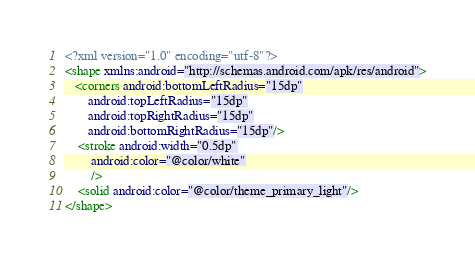<code> <loc_0><loc_0><loc_500><loc_500><_XML_><?xml version="1.0" encoding="utf-8"?>
<shape xmlns:android="http://schemas.android.com/apk/res/android">
   <corners android:bottomLeftRadius="15dp"
       android:topLeftRadius="15dp"
       android:topRightRadius="15dp"
       android:bottomRightRadius="15dp"/>
    <stroke android:width="0.5dp"
        android:color="@color/white"
        />
    <solid android:color="@color/theme_primary_light"/>
</shape></code> 